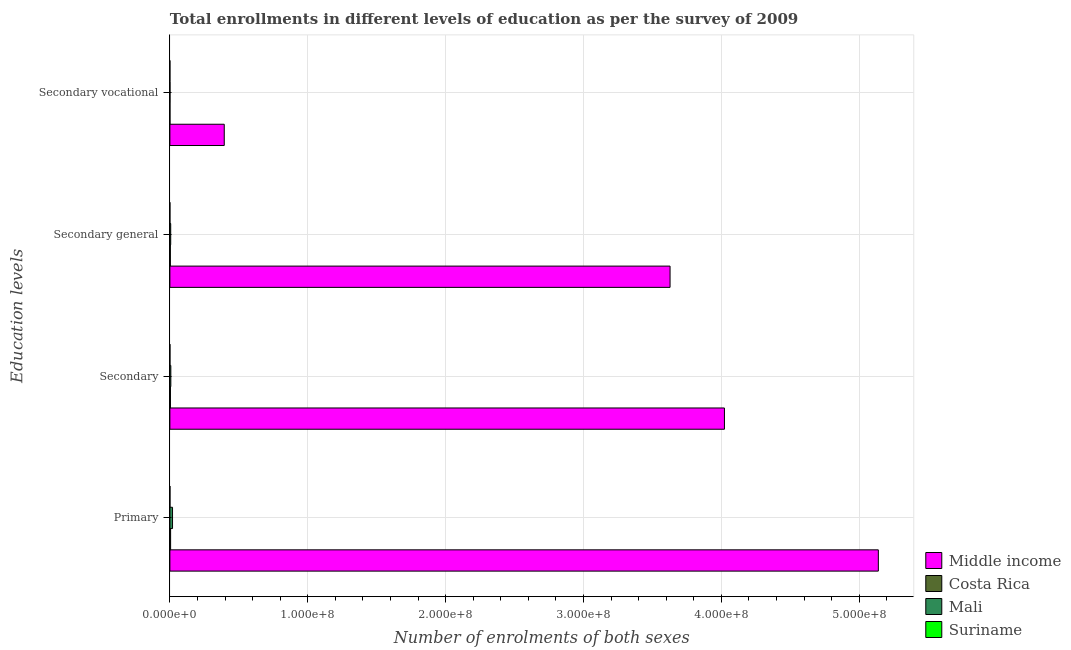What is the label of the 4th group of bars from the top?
Give a very brief answer. Primary. What is the number of enrolments in secondary education in Mali?
Provide a short and direct response. 6.86e+05. Across all countries, what is the maximum number of enrolments in secondary general education?
Keep it short and to the point. 3.63e+08. Across all countries, what is the minimum number of enrolments in secondary general education?
Your response must be concise. 2.53e+04. In which country was the number of enrolments in secondary vocational education maximum?
Offer a very short reply. Middle income. In which country was the number of enrolments in primary education minimum?
Your answer should be compact. Suriname. What is the total number of enrolments in secondary education in the graph?
Offer a terse response. 4.03e+08. What is the difference between the number of enrolments in secondary education in Mali and that in Costa Rica?
Your response must be concise. 2.80e+05. What is the difference between the number of enrolments in secondary general education in Mali and the number of enrolments in secondary education in Suriname?
Give a very brief answer. 5.50e+05. What is the average number of enrolments in secondary general education per country?
Offer a very short reply. 9.09e+07. What is the difference between the number of enrolments in secondary vocational education and number of enrolments in secondary education in Mali?
Provide a short and direct response. -5.97e+05. In how many countries, is the number of enrolments in secondary vocational education greater than 360000000 ?
Ensure brevity in your answer.  0. What is the ratio of the number of enrolments in secondary education in Mali to that in Costa Rica?
Offer a very short reply. 1.69. What is the difference between the highest and the second highest number of enrolments in secondary vocational education?
Offer a terse response. 3.94e+07. What is the difference between the highest and the lowest number of enrolments in secondary education?
Provide a short and direct response. 4.02e+08. In how many countries, is the number of enrolments in primary education greater than the average number of enrolments in primary education taken over all countries?
Your answer should be very brief. 1. Is the sum of the number of enrolments in secondary vocational education in Suriname and Mali greater than the maximum number of enrolments in secondary general education across all countries?
Ensure brevity in your answer.  No. Is it the case that in every country, the sum of the number of enrolments in secondary general education and number of enrolments in secondary vocational education is greater than the sum of number of enrolments in primary education and number of enrolments in secondary education?
Keep it short and to the point. No. What does the 2nd bar from the top in Primary represents?
Make the answer very short. Mali. What does the 4th bar from the bottom in Secondary vocational represents?
Your response must be concise. Suriname. Is it the case that in every country, the sum of the number of enrolments in primary education and number of enrolments in secondary education is greater than the number of enrolments in secondary general education?
Ensure brevity in your answer.  Yes. How many bars are there?
Provide a succinct answer. 16. How many countries are there in the graph?
Provide a short and direct response. 4. What is the difference between two consecutive major ticks on the X-axis?
Ensure brevity in your answer.  1.00e+08. Are the values on the major ticks of X-axis written in scientific E-notation?
Offer a very short reply. Yes. Does the graph contain any zero values?
Your answer should be very brief. No. Where does the legend appear in the graph?
Offer a very short reply. Bottom right. How many legend labels are there?
Your answer should be compact. 4. How are the legend labels stacked?
Offer a terse response. Vertical. What is the title of the graph?
Your answer should be very brief. Total enrollments in different levels of education as per the survey of 2009. What is the label or title of the X-axis?
Keep it short and to the point. Number of enrolments of both sexes. What is the label or title of the Y-axis?
Your answer should be compact. Education levels. What is the Number of enrolments of both sexes in Middle income in Primary?
Your answer should be very brief. 5.14e+08. What is the Number of enrolments of both sexes in Costa Rica in Primary?
Your answer should be very brief. 5.32e+05. What is the Number of enrolments of both sexes of Mali in Primary?
Offer a very short reply. 1.93e+06. What is the Number of enrolments of both sexes in Suriname in Primary?
Offer a terse response. 7.11e+04. What is the Number of enrolments of both sexes in Middle income in Secondary?
Ensure brevity in your answer.  4.02e+08. What is the Number of enrolments of both sexes of Costa Rica in Secondary?
Provide a succinct answer. 4.06e+05. What is the Number of enrolments of both sexes in Mali in Secondary?
Your response must be concise. 6.86e+05. What is the Number of enrolments of both sexes of Suriname in Secondary?
Offer a terse response. 4.72e+04. What is the Number of enrolments of both sexes in Middle income in Secondary general?
Offer a very short reply. 3.63e+08. What is the Number of enrolments of both sexes of Costa Rica in Secondary general?
Offer a very short reply. 3.44e+05. What is the Number of enrolments of both sexes of Mali in Secondary general?
Keep it short and to the point. 5.97e+05. What is the Number of enrolments of both sexes in Suriname in Secondary general?
Ensure brevity in your answer.  2.53e+04. What is the Number of enrolments of both sexes of Middle income in Secondary vocational?
Provide a succinct answer. 3.94e+07. What is the Number of enrolments of both sexes in Costa Rica in Secondary vocational?
Provide a succinct answer. 6.13e+04. What is the Number of enrolments of both sexes in Mali in Secondary vocational?
Give a very brief answer. 8.90e+04. What is the Number of enrolments of both sexes in Suriname in Secondary vocational?
Your answer should be compact. 2.19e+04. Across all Education levels, what is the maximum Number of enrolments of both sexes in Middle income?
Offer a terse response. 5.14e+08. Across all Education levels, what is the maximum Number of enrolments of both sexes in Costa Rica?
Your answer should be compact. 5.32e+05. Across all Education levels, what is the maximum Number of enrolments of both sexes of Mali?
Give a very brief answer. 1.93e+06. Across all Education levels, what is the maximum Number of enrolments of both sexes in Suriname?
Provide a short and direct response. 7.11e+04. Across all Education levels, what is the minimum Number of enrolments of both sexes in Middle income?
Give a very brief answer. 3.94e+07. Across all Education levels, what is the minimum Number of enrolments of both sexes in Costa Rica?
Your answer should be very brief. 6.13e+04. Across all Education levels, what is the minimum Number of enrolments of both sexes of Mali?
Ensure brevity in your answer.  8.90e+04. Across all Education levels, what is the minimum Number of enrolments of both sexes of Suriname?
Your answer should be compact. 2.19e+04. What is the total Number of enrolments of both sexes of Middle income in the graph?
Keep it short and to the point. 1.32e+09. What is the total Number of enrolments of both sexes in Costa Rica in the graph?
Ensure brevity in your answer.  1.34e+06. What is the total Number of enrolments of both sexes in Mali in the graph?
Offer a terse response. 3.30e+06. What is the total Number of enrolments of both sexes in Suriname in the graph?
Your answer should be compact. 1.66e+05. What is the difference between the Number of enrolments of both sexes of Middle income in Primary and that in Secondary?
Provide a succinct answer. 1.12e+08. What is the difference between the Number of enrolments of both sexes in Costa Rica in Primary and that in Secondary?
Keep it short and to the point. 1.26e+05. What is the difference between the Number of enrolments of both sexes in Mali in Primary and that in Secondary?
Your answer should be compact. 1.24e+06. What is the difference between the Number of enrolments of both sexes in Suriname in Primary and that in Secondary?
Your response must be concise. 2.39e+04. What is the difference between the Number of enrolments of both sexes in Middle income in Primary and that in Secondary general?
Offer a very short reply. 1.51e+08. What is the difference between the Number of enrolments of both sexes in Costa Rica in Primary and that in Secondary general?
Make the answer very short. 1.87e+05. What is the difference between the Number of enrolments of both sexes of Mali in Primary and that in Secondary general?
Make the answer very short. 1.33e+06. What is the difference between the Number of enrolments of both sexes of Suriname in Primary and that in Secondary general?
Your answer should be very brief. 4.58e+04. What is the difference between the Number of enrolments of both sexes in Middle income in Primary and that in Secondary vocational?
Your response must be concise. 4.74e+08. What is the difference between the Number of enrolments of both sexes of Costa Rica in Primary and that in Secondary vocational?
Ensure brevity in your answer.  4.70e+05. What is the difference between the Number of enrolments of both sexes in Mali in Primary and that in Secondary vocational?
Keep it short and to the point. 1.84e+06. What is the difference between the Number of enrolments of both sexes of Suriname in Primary and that in Secondary vocational?
Give a very brief answer. 4.92e+04. What is the difference between the Number of enrolments of both sexes of Middle income in Secondary and that in Secondary general?
Give a very brief answer. 3.94e+07. What is the difference between the Number of enrolments of both sexes of Costa Rica in Secondary and that in Secondary general?
Offer a very short reply. 6.13e+04. What is the difference between the Number of enrolments of both sexes of Mali in Secondary and that in Secondary general?
Offer a very short reply. 8.90e+04. What is the difference between the Number of enrolments of both sexes in Suriname in Secondary and that in Secondary general?
Provide a short and direct response. 2.19e+04. What is the difference between the Number of enrolments of both sexes in Middle income in Secondary and that in Secondary vocational?
Your answer should be very brief. 3.63e+08. What is the difference between the Number of enrolments of both sexes of Costa Rica in Secondary and that in Secondary vocational?
Give a very brief answer. 3.44e+05. What is the difference between the Number of enrolments of both sexes of Mali in Secondary and that in Secondary vocational?
Make the answer very short. 5.97e+05. What is the difference between the Number of enrolments of both sexes of Suriname in Secondary and that in Secondary vocational?
Give a very brief answer. 2.53e+04. What is the difference between the Number of enrolments of both sexes in Middle income in Secondary general and that in Secondary vocational?
Offer a terse response. 3.23e+08. What is the difference between the Number of enrolments of both sexes of Costa Rica in Secondary general and that in Secondary vocational?
Provide a succinct answer. 2.83e+05. What is the difference between the Number of enrolments of both sexes in Mali in Secondary general and that in Secondary vocational?
Keep it short and to the point. 5.08e+05. What is the difference between the Number of enrolments of both sexes of Suriname in Secondary general and that in Secondary vocational?
Give a very brief answer. 3427. What is the difference between the Number of enrolments of both sexes in Middle income in Primary and the Number of enrolments of both sexes in Costa Rica in Secondary?
Make the answer very short. 5.13e+08. What is the difference between the Number of enrolments of both sexes of Middle income in Primary and the Number of enrolments of both sexes of Mali in Secondary?
Make the answer very short. 5.13e+08. What is the difference between the Number of enrolments of both sexes in Middle income in Primary and the Number of enrolments of both sexes in Suriname in Secondary?
Keep it short and to the point. 5.14e+08. What is the difference between the Number of enrolments of both sexes in Costa Rica in Primary and the Number of enrolments of both sexes in Mali in Secondary?
Your answer should be compact. -1.54e+05. What is the difference between the Number of enrolments of both sexes of Costa Rica in Primary and the Number of enrolments of both sexes of Suriname in Secondary?
Give a very brief answer. 4.84e+05. What is the difference between the Number of enrolments of both sexes of Mali in Primary and the Number of enrolments of both sexes of Suriname in Secondary?
Offer a very short reply. 1.88e+06. What is the difference between the Number of enrolments of both sexes of Middle income in Primary and the Number of enrolments of both sexes of Costa Rica in Secondary general?
Keep it short and to the point. 5.14e+08. What is the difference between the Number of enrolments of both sexes of Middle income in Primary and the Number of enrolments of both sexes of Mali in Secondary general?
Keep it short and to the point. 5.13e+08. What is the difference between the Number of enrolments of both sexes in Middle income in Primary and the Number of enrolments of both sexes in Suriname in Secondary general?
Your answer should be compact. 5.14e+08. What is the difference between the Number of enrolments of both sexes in Costa Rica in Primary and the Number of enrolments of both sexes in Mali in Secondary general?
Your answer should be very brief. -6.54e+04. What is the difference between the Number of enrolments of both sexes of Costa Rica in Primary and the Number of enrolments of both sexes of Suriname in Secondary general?
Provide a succinct answer. 5.06e+05. What is the difference between the Number of enrolments of both sexes of Mali in Primary and the Number of enrolments of both sexes of Suriname in Secondary general?
Provide a short and direct response. 1.90e+06. What is the difference between the Number of enrolments of both sexes in Middle income in Primary and the Number of enrolments of both sexes in Costa Rica in Secondary vocational?
Ensure brevity in your answer.  5.14e+08. What is the difference between the Number of enrolments of both sexes of Middle income in Primary and the Number of enrolments of both sexes of Mali in Secondary vocational?
Your answer should be very brief. 5.14e+08. What is the difference between the Number of enrolments of both sexes in Middle income in Primary and the Number of enrolments of both sexes in Suriname in Secondary vocational?
Keep it short and to the point. 5.14e+08. What is the difference between the Number of enrolments of both sexes in Costa Rica in Primary and the Number of enrolments of both sexes in Mali in Secondary vocational?
Ensure brevity in your answer.  4.43e+05. What is the difference between the Number of enrolments of both sexes of Costa Rica in Primary and the Number of enrolments of both sexes of Suriname in Secondary vocational?
Provide a succinct answer. 5.10e+05. What is the difference between the Number of enrolments of both sexes in Mali in Primary and the Number of enrolments of both sexes in Suriname in Secondary vocational?
Your answer should be very brief. 1.90e+06. What is the difference between the Number of enrolments of both sexes of Middle income in Secondary and the Number of enrolments of both sexes of Costa Rica in Secondary general?
Make the answer very short. 4.02e+08. What is the difference between the Number of enrolments of both sexes of Middle income in Secondary and the Number of enrolments of both sexes of Mali in Secondary general?
Your response must be concise. 4.02e+08. What is the difference between the Number of enrolments of both sexes of Middle income in Secondary and the Number of enrolments of both sexes of Suriname in Secondary general?
Offer a terse response. 4.02e+08. What is the difference between the Number of enrolments of both sexes of Costa Rica in Secondary and the Number of enrolments of both sexes of Mali in Secondary general?
Provide a succinct answer. -1.91e+05. What is the difference between the Number of enrolments of both sexes of Costa Rica in Secondary and the Number of enrolments of both sexes of Suriname in Secondary general?
Give a very brief answer. 3.80e+05. What is the difference between the Number of enrolments of both sexes of Mali in Secondary and the Number of enrolments of both sexes of Suriname in Secondary general?
Ensure brevity in your answer.  6.61e+05. What is the difference between the Number of enrolments of both sexes in Middle income in Secondary and the Number of enrolments of both sexes in Costa Rica in Secondary vocational?
Give a very brief answer. 4.02e+08. What is the difference between the Number of enrolments of both sexes of Middle income in Secondary and the Number of enrolments of both sexes of Mali in Secondary vocational?
Give a very brief answer. 4.02e+08. What is the difference between the Number of enrolments of both sexes in Middle income in Secondary and the Number of enrolments of both sexes in Suriname in Secondary vocational?
Give a very brief answer. 4.02e+08. What is the difference between the Number of enrolments of both sexes of Costa Rica in Secondary and the Number of enrolments of both sexes of Mali in Secondary vocational?
Offer a very short reply. 3.17e+05. What is the difference between the Number of enrolments of both sexes of Costa Rica in Secondary and the Number of enrolments of both sexes of Suriname in Secondary vocational?
Provide a short and direct response. 3.84e+05. What is the difference between the Number of enrolments of both sexes in Mali in Secondary and the Number of enrolments of both sexes in Suriname in Secondary vocational?
Your response must be concise. 6.64e+05. What is the difference between the Number of enrolments of both sexes in Middle income in Secondary general and the Number of enrolments of both sexes in Costa Rica in Secondary vocational?
Offer a terse response. 3.63e+08. What is the difference between the Number of enrolments of both sexes of Middle income in Secondary general and the Number of enrolments of both sexes of Mali in Secondary vocational?
Give a very brief answer. 3.63e+08. What is the difference between the Number of enrolments of both sexes in Middle income in Secondary general and the Number of enrolments of both sexes in Suriname in Secondary vocational?
Your answer should be very brief. 3.63e+08. What is the difference between the Number of enrolments of both sexes in Costa Rica in Secondary general and the Number of enrolments of both sexes in Mali in Secondary vocational?
Your answer should be very brief. 2.55e+05. What is the difference between the Number of enrolments of both sexes in Costa Rica in Secondary general and the Number of enrolments of both sexes in Suriname in Secondary vocational?
Offer a terse response. 3.22e+05. What is the difference between the Number of enrolments of both sexes of Mali in Secondary general and the Number of enrolments of both sexes of Suriname in Secondary vocational?
Provide a succinct answer. 5.75e+05. What is the average Number of enrolments of both sexes in Middle income per Education levels?
Offer a very short reply. 3.30e+08. What is the average Number of enrolments of both sexes in Costa Rica per Education levels?
Provide a succinct answer. 3.36e+05. What is the average Number of enrolments of both sexes in Mali per Education levels?
Your response must be concise. 8.25e+05. What is the average Number of enrolments of both sexes of Suriname per Education levels?
Offer a very short reply. 4.14e+04. What is the difference between the Number of enrolments of both sexes in Middle income and Number of enrolments of both sexes in Costa Rica in Primary?
Your answer should be very brief. 5.13e+08. What is the difference between the Number of enrolments of both sexes of Middle income and Number of enrolments of both sexes of Mali in Primary?
Provide a short and direct response. 5.12e+08. What is the difference between the Number of enrolments of both sexes of Middle income and Number of enrolments of both sexes of Suriname in Primary?
Provide a succinct answer. 5.14e+08. What is the difference between the Number of enrolments of both sexes in Costa Rica and Number of enrolments of both sexes in Mali in Primary?
Provide a short and direct response. -1.39e+06. What is the difference between the Number of enrolments of both sexes in Costa Rica and Number of enrolments of both sexes in Suriname in Primary?
Make the answer very short. 4.61e+05. What is the difference between the Number of enrolments of both sexes in Mali and Number of enrolments of both sexes in Suriname in Primary?
Offer a very short reply. 1.86e+06. What is the difference between the Number of enrolments of both sexes of Middle income and Number of enrolments of both sexes of Costa Rica in Secondary?
Make the answer very short. 4.02e+08. What is the difference between the Number of enrolments of both sexes of Middle income and Number of enrolments of both sexes of Mali in Secondary?
Offer a terse response. 4.02e+08. What is the difference between the Number of enrolments of both sexes in Middle income and Number of enrolments of both sexes in Suriname in Secondary?
Provide a succinct answer. 4.02e+08. What is the difference between the Number of enrolments of both sexes of Costa Rica and Number of enrolments of both sexes of Mali in Secondary?
Provide a succinct answer. -2.80e+05. What is the difference between the Number of enrolments of both sexes of Costa Rica and Number of enrolments of both sexes of Suriname in Secondary?
Give a very brief answer. 3.58e+05. What is the difference between the Number of enrolments of both sexes of Mali and Number of enrolments of both sexes of Suriname in Secondary?
Offer a terse response. 6.39e+05. What is the difference between the Number of enrolments of both sexes of Middle income and Number of enrolments of both sexes of Costa Rica in Secondary general?
Make the answer very short. 3.62e+08. What is the difference between the Number of enrolments of both sexes in Middle income and Number of enrolments of both sexes in Mali in Secondary general?
Provide a succinct answer. 3.62e+08. What is the difference between the Number of enrolments of both sexes in Middle income and Number of enrolments of both sexes in Suriname in Secondary general?
Offer a terse response. 3.63e+08. What is the difference between the Number of enrolments of both sexes of Costa Rica and Number of enrolments of both sexes of Mali in Secondary general?
Your response must be concise. -2.53e+05. What is the difference between the Number of enrolments of both sexes in Costa Rica and Number of enrolments of both sexes in Suriname in Secondary general?
Offer a terse response. 3.19e+05. What is the difference between the Number of enrolments of both sexes in Mali and Number of enrolments of both sexes in Suriname in Secondary general?
Your answer should be very brief. 5.72e+05. What is the difference between the Number of enrolments of both sexes in Middle income and Number of enrolments of both sexes in Costa Rica in Secondary vocational?
Keep it short and to the point. 3.94e+07. What is the difference between the Number of enrolments of both sexes in Middle income and Number of enrolments of both sexes in Mali in Secondary vocational?
Provide a short and direct response. 3.94e+07. What is the difference between the Number of enrolments of both sexes of Middle income and Number of enrolments of both sexes of Suriname in Secondary vocational?
Offer a very short reply. 3.94e+07. What is the difference between the Number of enrolments of both sexes of Costa Rica and Number of enrolments of both sexes of Mali in Secondary vocational?
Your answer should be very brief. -2.77e+04. What is the difference between the Number of enrolments of both sexes of Costa Rica and Number of enrolments of both sexes of Suriname in Secondary vocational?
Your answer should be compact. 3.94e+04. What is the difference between the Number of enrolments of both sexes in Mali and Number of enrolments of both sexes in Suriname in Secondary vocational?
Offer a very short reply. 6.71e+04. What is the ratio of the Number of enrolments of both sexes of Middle income in Primary to that in Secondary?
Your response must be concise. 1.28. What is the ratio of the Number of enrolments of both sexes in Costa Rica in Primary to that in Secondary?
Your answer should be very brief. 1.31. What is the ratio of the Number of enrolments of both sexes of Mali in Primary to that in Secondary?
Your response must be concise. 2.81. What is the ratio of the Number of enrolments of both sexes in Suriname in Primary to that in Secondary?
Offer a terse response. 1.51. What is the ratio of the Number of enrolments of both sexes of Middle income in Primary to that in Secondary general?
Offer a terse response. 1.42. What is the ratio of the Number of enrolments of both sexes in Costa Rica in Primary to that in Secondary general?
Your answer should be very brief. 1.54. What is the ratio of the Number of enrolments of both sexes in Mali in Primary to that in Secondary general?
Make the answer very short. 3.23. What is the ratio of the Number of enrolments of both sexes in Suriname in Primary to that in Secondary general?
Keep it short and to the point. 2.81. What is the ratio of the Number of enrolments of both sexes of Middle income in Primary to that in Secondary vocational?
Your response must be concise. 13.03. What is the ratio of the Number of enrolments of both sexes of Costa Rica in Primary to that in Secondary vocational?
Offer a very short reply. 8.67. What is the ratio of the Number of enrolments of both sexes of Mali in Primary to that in Secondary vocational?
Provide a succinct answer. 21.64. What is the ratio of the Number of enrolments of both sexes in Suriname in Primary to that in Secondary vocational?
Keep it short and to the point. 3.25. What is the ratio of the Number of enrolments of both sexes of Middle income in Secondary to that in Secondary general?
Offer a very short reply. 1.11. What is the ratio of the Number of enrolments of both sexes of Costa Rica in Secondary to that in Secondary general?
Offer a terse response. 1.18. What is the ratio of the Number of enrolments of both sexes of Mali in Secondary to that in Secondary general?
Provide a succinct answer. 1.15. What is the ratio of the Number of enrolments of both sexes in Suriname in Secondary to that in Secondary general?
Make the answer very short. 1.86. What is the ratio of the Number of enrolments of both sexes in Middle income in Secondary to that in Secondary vocational?
Ensure brevity in your answer.  10.2. What is the ratio of the Number of enrolments of both sexes of Costa Rica in Secondary to that in Secondary vocational?
Keep it short and to the point. 6.62. What is the ratio of the Number of enrolments of both sexes in Mali in Secondary to that in Secondary vocational?
Give a very brief answer. 7.71. What is the ratio of the Number of enrolments of both sexes in Suriname in Secondary to that in Secondary vocational?
Your response must be concise. 2.16. What is the ratio of the Number of enrolments of both sexes in Middle income in Secondary general to that in Secondary vocational?
Offer a terse response. 9.2. What is the ratio of the Number of enrolments of both sexes of Costa Rica in Secondary general to that in Secondary vocational?
Ensure brevity in your answer.  5.62. What is the ratio of the Number of enrolments of both sexes of Mali in Secondary general to that in Secondary vocational?
Your response must be concise. 6.71. What is the ratio of the Number of enrolments of both sexes in Suriname in Secondary general to that in Secondary vocational?
Keep it short and to the point. 1.16. What is the difference between the highest and the second highest Number of enrolments of both sexes in Middle income?
Your answer should be very brief. 1.12e+08. What is the difference between the highest and the second highest Number of enrolments of both sexes of Costa Rica?
Offer a terse response. 1.26e+05. What is the difference between the highest and the second highest Number of enrolments of both sexes of Mali?
Offer a very short reply. 1.24e+06. What is the difference between the highest and the second highest Number of enrolments of both sexes of Suriname?
Your response must be concise. 2.39e+04. What is the difference between the highest and the lowest Number of enrolments of both sexes in Middle income?
Offer a very short reply. 4.74e+08. What is the difference between the highest and the lowest Number of enrolments of both sexes of Costa Rica?
Make the answer very short. 4.70e+05. What is the difference between the highest and the lowest Number of enrolments of both sexes of Mali?
Ensure brevity in your answer.  1.84e+06. What is the difference between the highest and the lowest Number of enrolments of both sexes of Suriname?
Provide a short and direct response. 4.92e+04. 